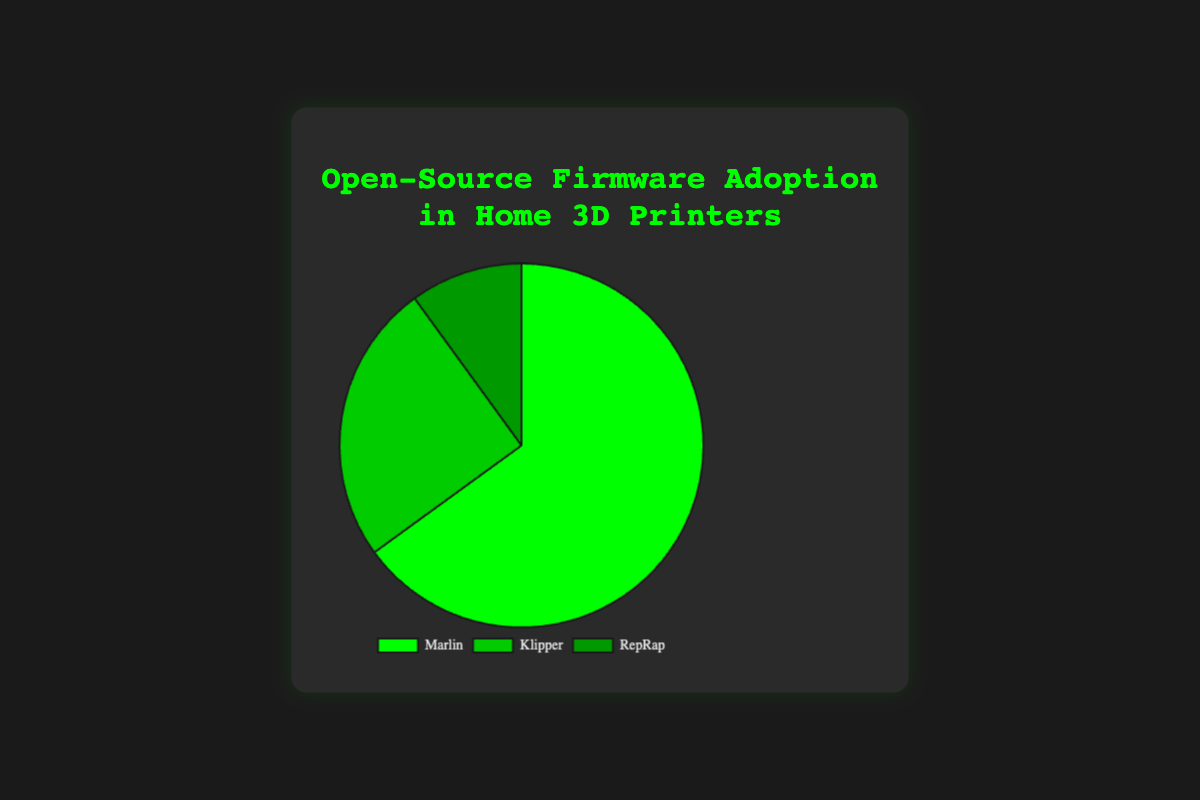What percentage of adoption does Marlin have? The figure shows that Marlin has an adoption rate of 65%.
Answer: 65% Which firmware has the lowest adoption rate? Comparing the three segments of the pie chart, RepRap has the smallest segment, indicating it has the lowest adoption rate.
Answer: RepRap What is the total adoption rate of Klipper and RepRap combined? Adding the adoption rates of Klipper (25%) and RepRap (10%) gives 25% + 10% = 35%.
Answer: 35% How does the adoption rate of Marlin compare to Klipper? Marlin has an adoption rate of 65%, while Klipper has 25%. Marlin's adoption rate is 65% - 25% = 40% higher than Klipper's.
Answer: 40% higher What color represents Klipper on the pie chart? By identifying the color associated with Klipper, which is the second label, we see that Klipper is represented by a darker green color.
Answer: Darker green What fraction of the adoption rate does RepRap account for compared to Marlin? RepRap has an adoption rate of 10% and Marlin has 65%. The fraction is calculated as 10 / 65, which simplifies to approximately 1/6.5.
Answer: 1/6.5 Which firmware occupies the largest portion of the pie chart? Marlin has the largest segment in the pie chart, indicating it occupies the largest portion.
Answer: Marlin If you were to visually split the pie chart in half, would Marlin's adoption rate appear on both sides? Marlin’s segment constitutes 65% of the pie chart, which is more than half. Thus, Marlin's segment would span both halves of a split pie chart.
Answer: Yes How many degrees of the pie chart is occupied by Klipper's adoption rate, given that the whole circle is 360 degrees? Klipper has an adoption rate of 25%. Therefore, the segment is 25% of 360 degrees, which is 0.25 * 360 = 90 degrees.
Answer: 90 degrees If Marlin’s adoption rate were to increase by 10%, what would be the new total adoption rate for all firmwares? Current adoption rates sum up to 100% (since they represent the whole pie). If Marlin’s rate increases by 10%, the new rate would exceed 100%, which means 65% + 10% = 75% for Marlin, keeping the remaining 25% constant without changing the total sum.
Answer: Data inconsistency (exceeds 100%) 